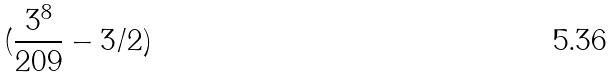Convert formula to latex. <formula><loc_0><loc_0><loc_500><loc_500>( \frac { 3 ^ { 8 } } { 2 0 9 } - 3 / 2 )</formula> 